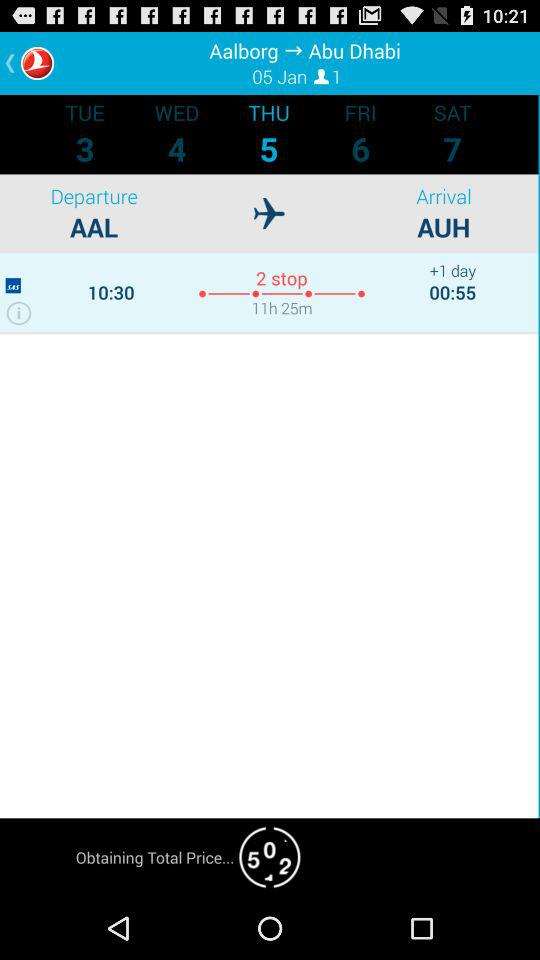What is the travel time from AAL to AUH? The travel time is 11 hours and 25 minutes. 